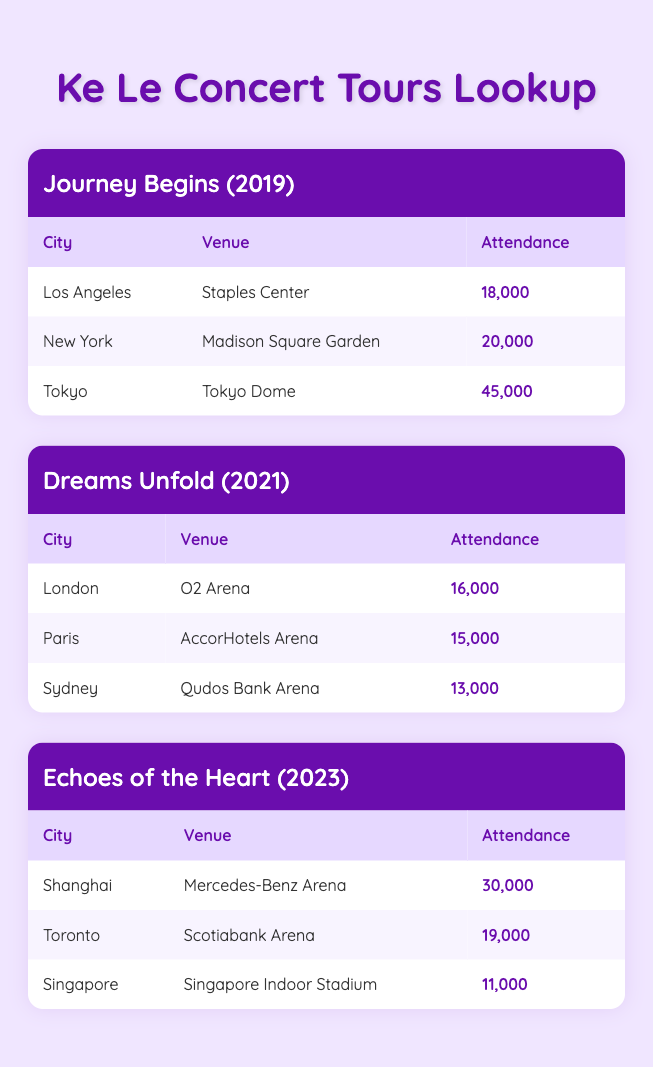What was the highest attendance recorded during the Journey Begins tour? The table shows attendance figures for the Journey Begins tour across three locations: Los Angeles (18,000), New York (20,000), and Tokyo (45,000). The highest attendance is 45,000 in Tokyo.
Answer: 45,000 Which city had the lowest attendance during the Dreams Unfold tour? In the Dreams Unfold tour, the attendance figures for the three locations are: London (16,000), Paris (15,000), and Sydney (13,000). Sydney has the lowest attendance at 13,000.
Answer: Sydney What is the total attendance for the Echoes of the Heart tour? The attendance figures for the Echoes of the Heart tour are: Shanghai (30,000), Toronto (19,000), and Singapore (11,000). Adding these figures together gives: 30,000 + 19,000 + 11,000 = 60,000.
Answer: 60,000 Is it true that the attendance in New York was higher than in London? The attendance in New York during the Journey Begins tour was 20,000, while the attendance in London during the Dreams Unfold tour was 16,000. Since 20,000 is greater than 16,000, the statement is true.
Answer: Yes Which tour had the highest average attendance across its locations? For the Journey Begins tour, the average attendance can be calculated as (18,000 + 20,000 + 45,000) / 3 = 27,667. For the Dreams Unfold tour, the average is (16,000 + 15,000 + 13,000) / 3 = 14,667. The Echoes of the Heart tour's average is (30,000 + 19,000 + 11,000) / 3 = 20,000. Comparing these averages shows that the Journey Begins tour had the highest average attendance of 27,667.
Answer: Journey Begins What was the combined attendance of the tours held in 2021 and 2023? To find the combined attendance, we first sum the attendance for each tour: Dreams Unfold (2021): 16,000 + 15,000 + 13,000 = 44,000. Echoes of the Heart (2023): 30,000 + 19,000 + 11,000 = 60,000. The total is then 44,000 + 60,000 = 104,000.
Answer: 104,000 